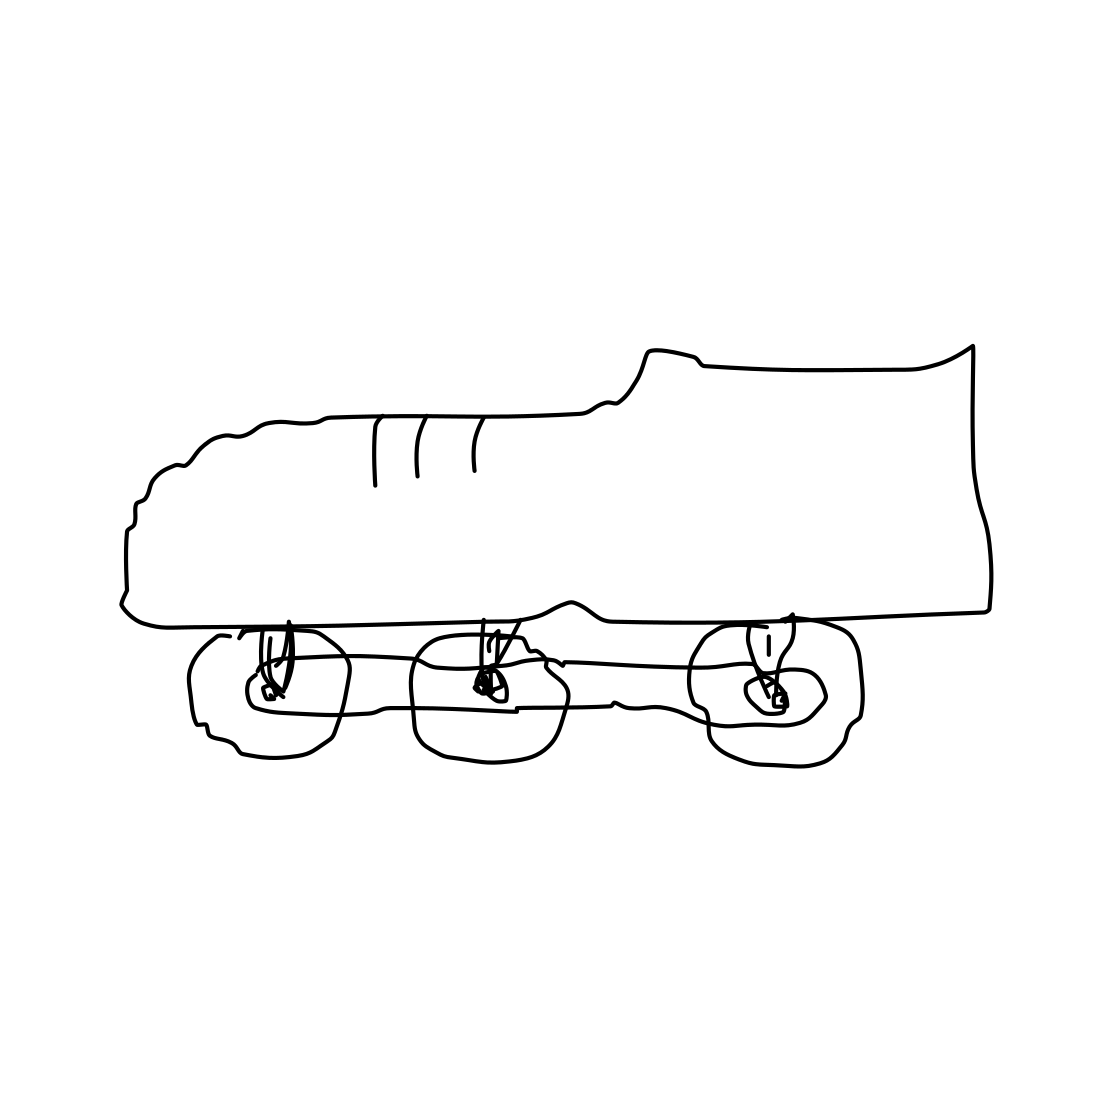What are the potential advantages and disadvantages of sneaker-skates? Advantages of sneaker-skates include enhanced mobility, the convenience of not needing to change footwear, and potential fun and exercise. However, disadvantages might include the added weight, potential awkwardness in certain terrains, and safety concerns during transitions between walking and skating. Is this sort of product widely available? As of now, products like these are more conceptual and less commonly found in mainstream markets. They might exist in niche markets or as custom builds by enthusiasts. The widespread availability would depend on consumer interest and manufacturing feasibility. 